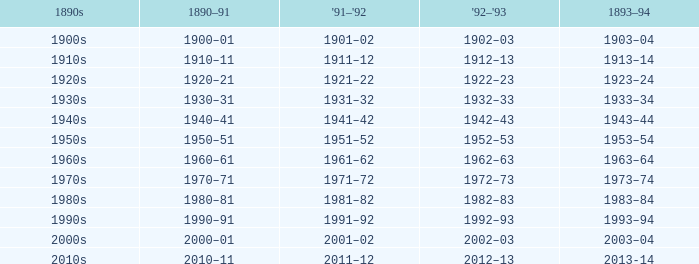What is the year from 1891-92 from the years 1890s to the 1960s? 1961–62. 